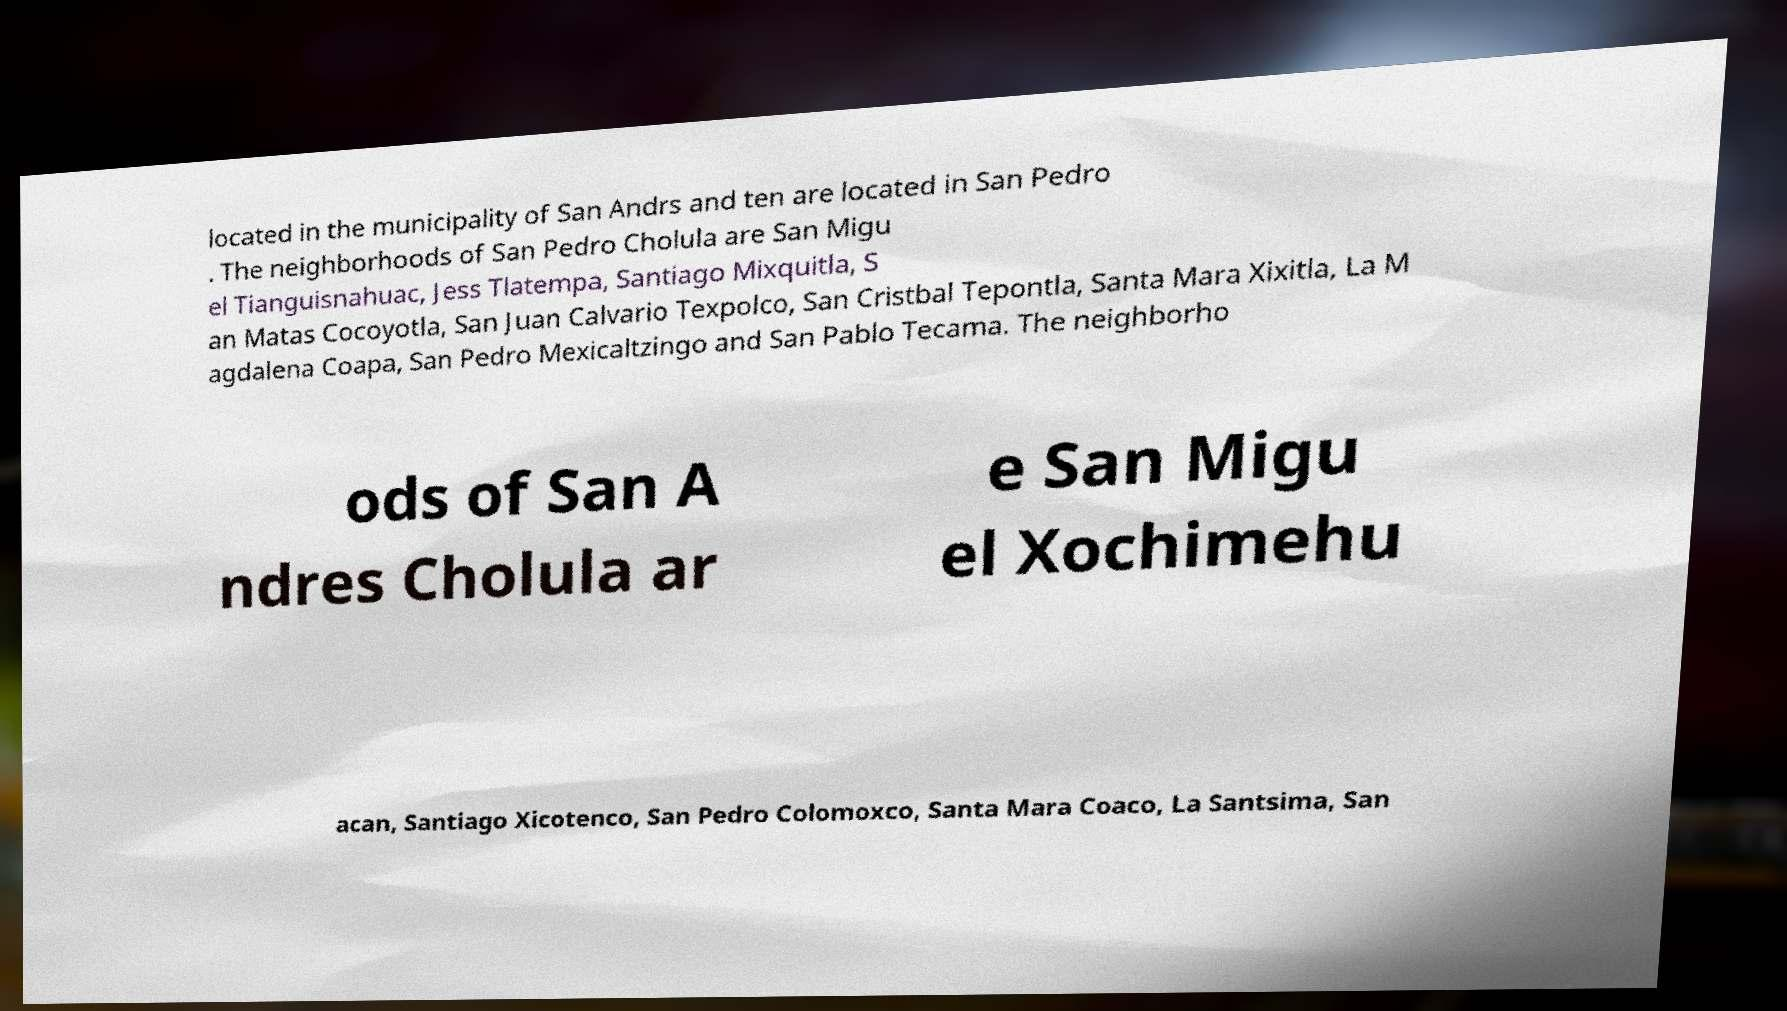Can you read and provide the text displayed in the image?This photo seems to have some interesting text. Can you extract and type it out for me? located in the municipality of San Andrs and ten are located in San Pedro . The neighborhoods of San Pedro Cholula are San Migu el Tianguisnahuac, Jess Tlatempa, Santiago Mixquitla, S an Matas Cocoyotla, San Juan Calvario Texpolco, San Cristbal Tepontla, Santa Mara Xixitla, La M agdalena Coapa, San Pedro Mexicaltzingo and San Pablo Tecama. The neighborho ods of San A ndres Cholula ar e San Migu el Xochimehu acan, Santiago Xicotenco, San Pedro Colomoxco, Santa Mara Coaco, La Santsima, San 